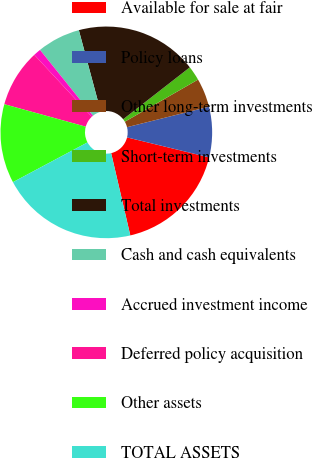Convert chart to OTSL. <chart><loc_0><loc_0><loc_500><loc_500><pie_chart><fcel>Available for sale at fair<fcel>Policy loans<fcel>Other long-term investments<fcel>Short-term investments<fcel>Total investments<fcel>Cash and cash equivalents<fcel>Accrued investment income<fcel>Deferred policy acquisition<fcel>Other assets<fcel>TOTAL ASSETS<nl><fcel>17.56%<fcel>7.7%<fcel>4.41%<fcel>2.22%<fcel>18.65%<fcel>6.6%<fcel>1.13%<fcel>8.8%<fcel>12.08%<fcel>20.84%<nl></chart> 